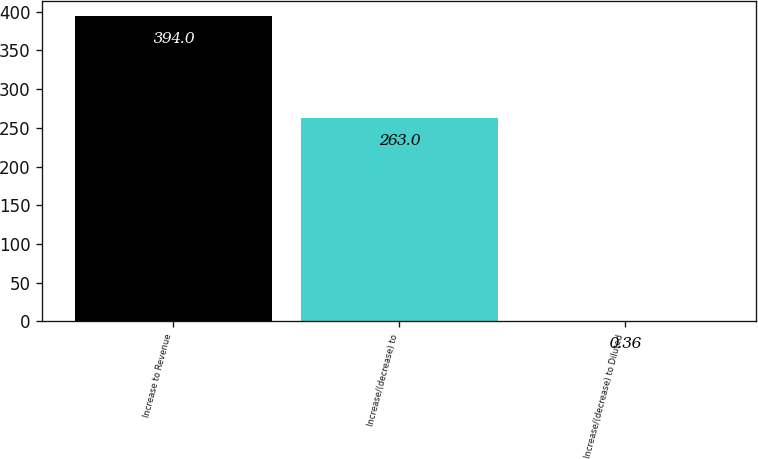Convert chart to OTSL. <chart><loc_0><loc_0><loc_500><loc_500><bar_chart><fcel>Increase to Revenue<fcel>Increase/(decrease) to<fcel>Increase/(decrease) to Diluted<nl><fcel>394<fcel>263<fcel>0.36<nl></chart> 